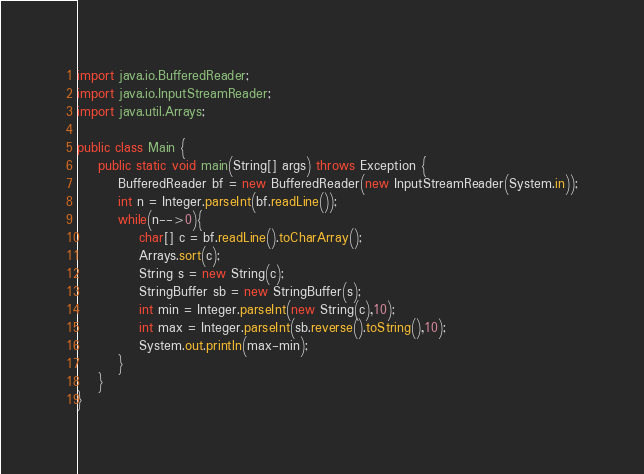<code> <loc_0><loc_0><loc_500><loc_500><_Java_>import java.io.BufferedReader;
import java.io.InputStreamReader;
import java.util.Arrays;

public class Main {
	public static void main(String[] args) throws Exception {
		BufferedReader bf = new BufferedReader(new InputStreamReader(System.in));
		int n = Integer.parseInt(bf.readLine());
		while(n-->0){
			char[] c = bf.readLine().toCharArray();
			Arrays.sort(c);
			String s = new String(c);
			StringBuffer sb = new StringBuffer(s);
			int min = Integer.parseInt(new String(c),10);
			int max = Integer.parseInt(sb.reverse().toString(),10);
			System.out.println(max-min);
		}
	}
}</code> 